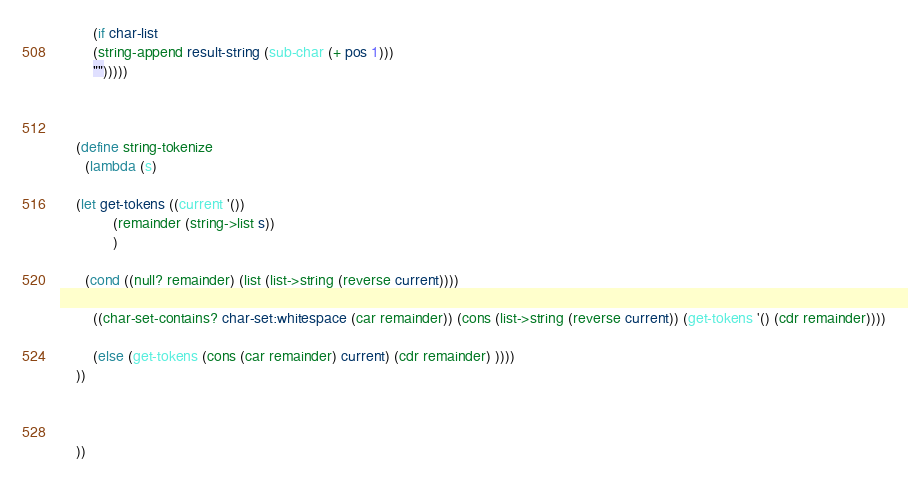<code> <loc_0><loc_0><loc_500><loc_500><_Scheme_>
	    (if char-list 
		(string-append result-string (sub-char (+ pos 1)))
		"")))))



    (define string-tokenize
      (lambda (s)

	(let get-tokens ((current '())
			 (remainder (string->list s))
			 )

	  (cond ((null? remainder) (list (list->string (reverse current))))

		((char-set-contains? char-set:whitespace (car remainder)) (cons (list->string (reverse current)) (get-tokens '() (cdr remainder))))

		(else (get-tokens (cons (car remainder) current) (cdr remainder) ))))
	))
    


    ))</code> 